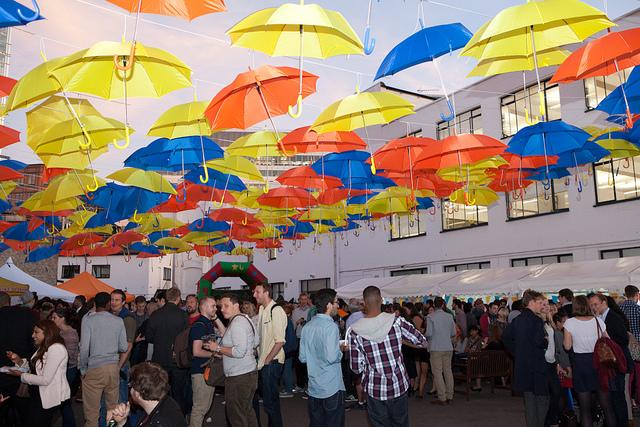Are most people sitting or standing?
Concise answer only. Standing. Was this picture taken outside or inside?
Write a very short answer. Outside. How many umbrellas are shown?
Write a very short answer. 50. Is this a calm picture?
Short answer required. No. How many umbrellas are there?
Short answer required. Many. Are all umbrellas the same color?
Concise answer only. No. Are the umbrellas planning on attacking?
Keep it brief. No. How many umbrellas?
Short answer required. Many. Why are there so many people in this picture?
Be succinct. Party. How many black umbrellas?
Be succinct. 0. What color are the largest umbrellas?
Write a very short answer. Yellow. 